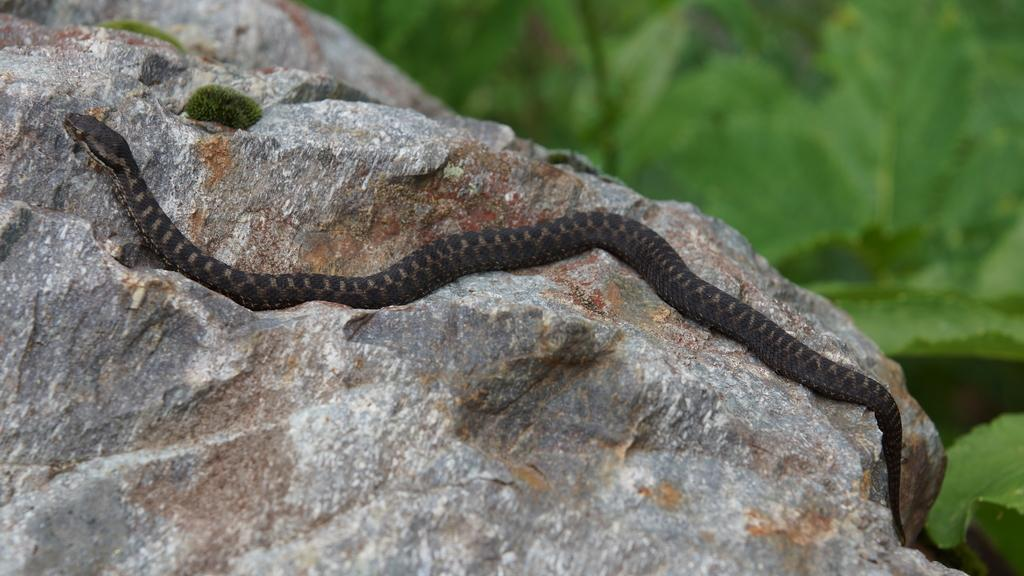What animal is present in the image? There is a snake in the image. Where is the snake located? The snake is on a rock. What can be seen in the background of the image? There are plants in the background of the image. When was the image taken? The image was taken during the day. How many ducks are sitting in the crate next to the snake in the image? There are no ducks or crates present in the image; it features a snake on a rock with plants in the background. 